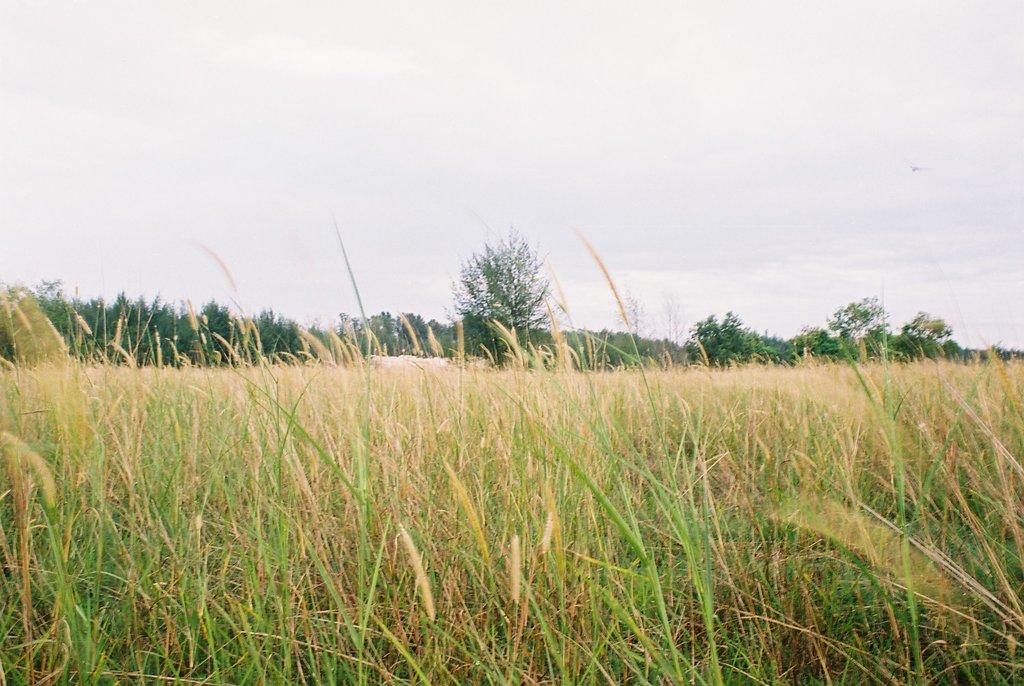What type of vegetation is in the foreground of the image? There is grass in the foreground of the image. What can be seen in the middle of the image? There are trees in the middle of the image. What is visible at the top of the image? The sky is visible at the top of the image. How many chickens are standing on the grass in the image? There are no chickens present in the image; it features grass, trees, and the sky. What is the size of the station in the image? There is no station present in the image; it features grass, trees, and the sky. 